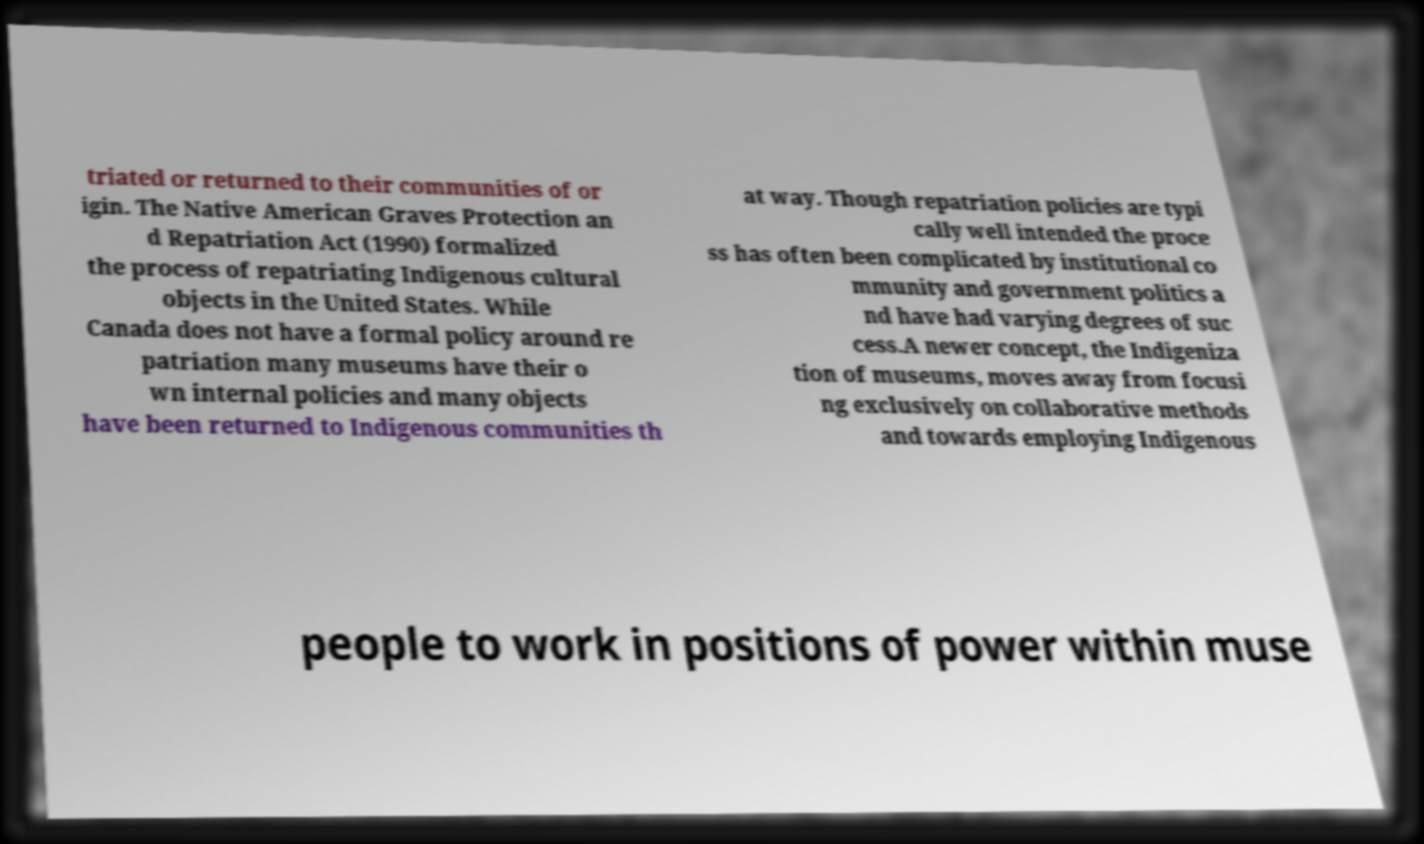Could you assist in decoding the text presented in this image and type it out clearly? triated or returned to their communities of or igin. The Native American Graves Protection an d Repatriation Act (1990) formalized the process of repatriating Indigenous cultural objects in the United States. While Canada does not have a formal policy around re patriation many museums have their o wn internal policies and many objects have been returned to Indigenous communities th at way. Though repatriation policies are typi cally well intended the proce ss has often been complicated by institutional co mmunity and government politics a nd have had varying degrees of suc cess.A newer concept, the Indigeniza tion of museums, moves away from focusi ng exclusively on collaborative methods and towards employing Indigenous people to work in positions of power within muse 